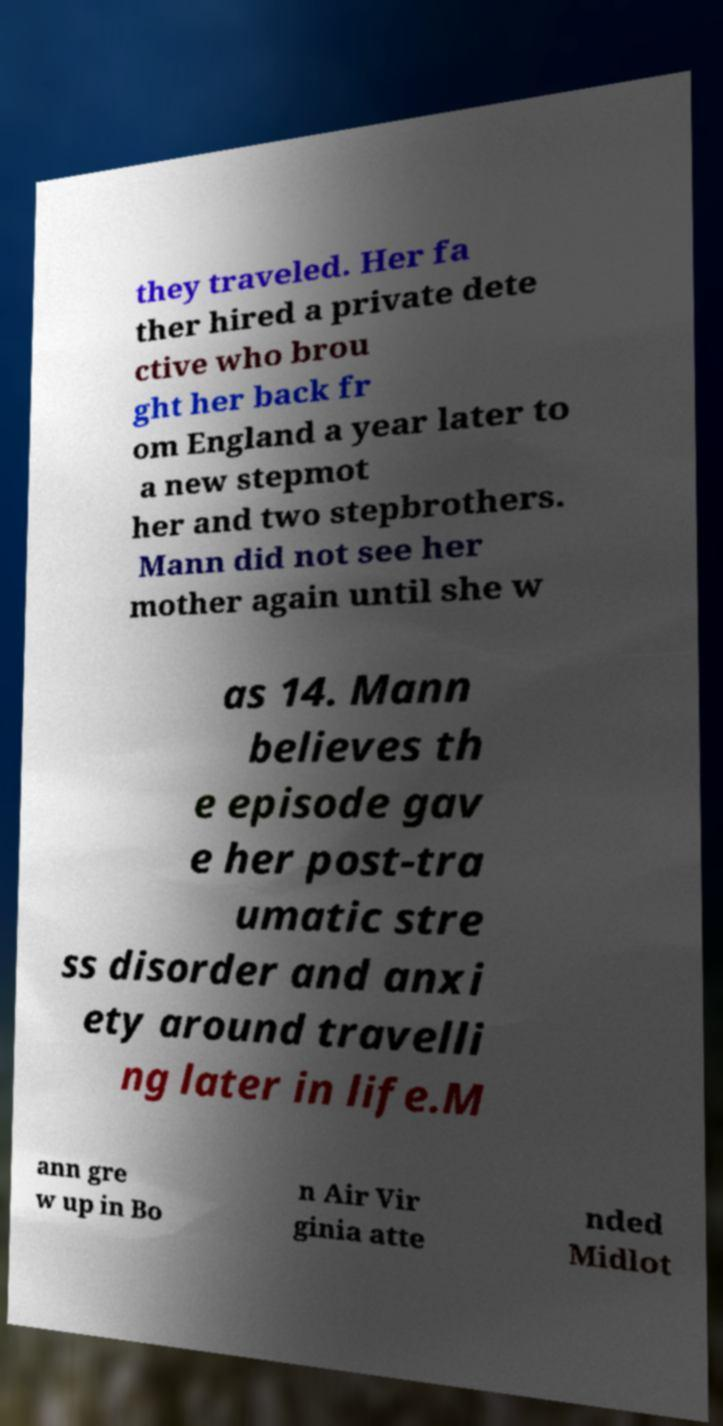There's text embedded in this image that I need extracted. Can you transcribe it verbatim? they traveled. Her fa ther hired a private dete ctive who brou ght her back fr om England a year later to a new stepmot her and two stepbrothers. Mann did not see her mother again until she w as 14. Mann believes th e episode gav e her post-tra umatic stre ss disorder and anxi ety around travelli ng later in life.M ann gre w up in Bo n Air Vir ginia atte nded Midlot 